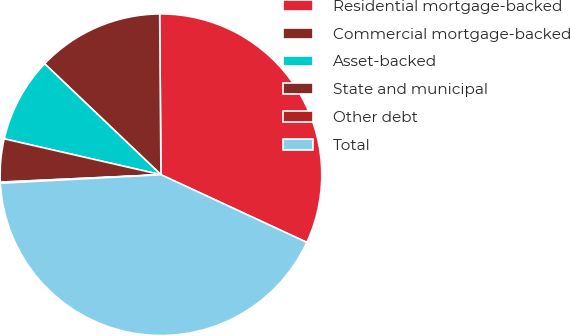Convert chart to OTSL. <chart><loc_0><loc_0><loc_500><loc_500><pie_chart><fcel>Residential mortgage-backed<fcel>Commercial mortgage-backed<fcel>Asset-backed<fcel>State and municipal<fcel>Other debt<fcel>Total<nl><fcel>32.04%<fcel>12.75%<fcel>8.54%<fcel>4.32%<fcel>0.11%<fcel>42.24%<nl></chart> 